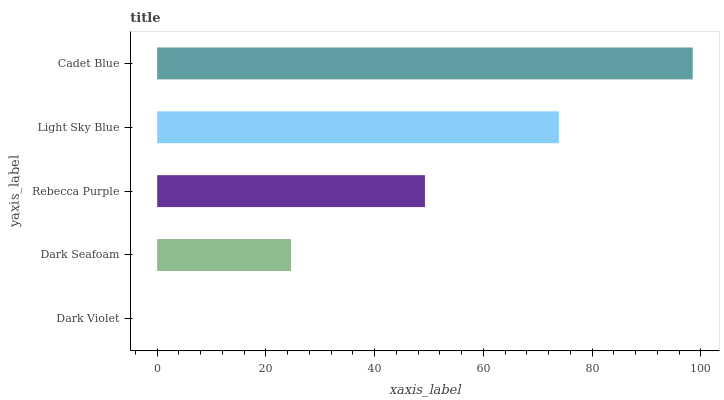Is Dark Violet the minimum?
Answer yes or no. Yes. Is Cadet Blue the maximum?
Answer yes or no. Yes. Is Dark Seafoam the minimum?
Answer yes or no. No. Is Dark Seafoam the maximum?
Answer yes or no. No. Is Dark Seafoam greater than Dark Violet?
Answer yes or no. Yes. Is Dark Violet less than Dark Seafoam?
Answer yes or no. Yes. Is Dark Violet greater than Dark Seafoam?
Answer yes or no. No. Is Dark Seafoam less than Dark Violet?
Answer yes or no. No. Is Rebecca Purple the high median?
Answer yes or no. Yes. Is Rebecca Purple the low median?
Answer yes or no. Yes. Is Dark Violet the high median?
Answer yes or no. No. Is Dark Violet the low median?
Answer yes or no. No. 